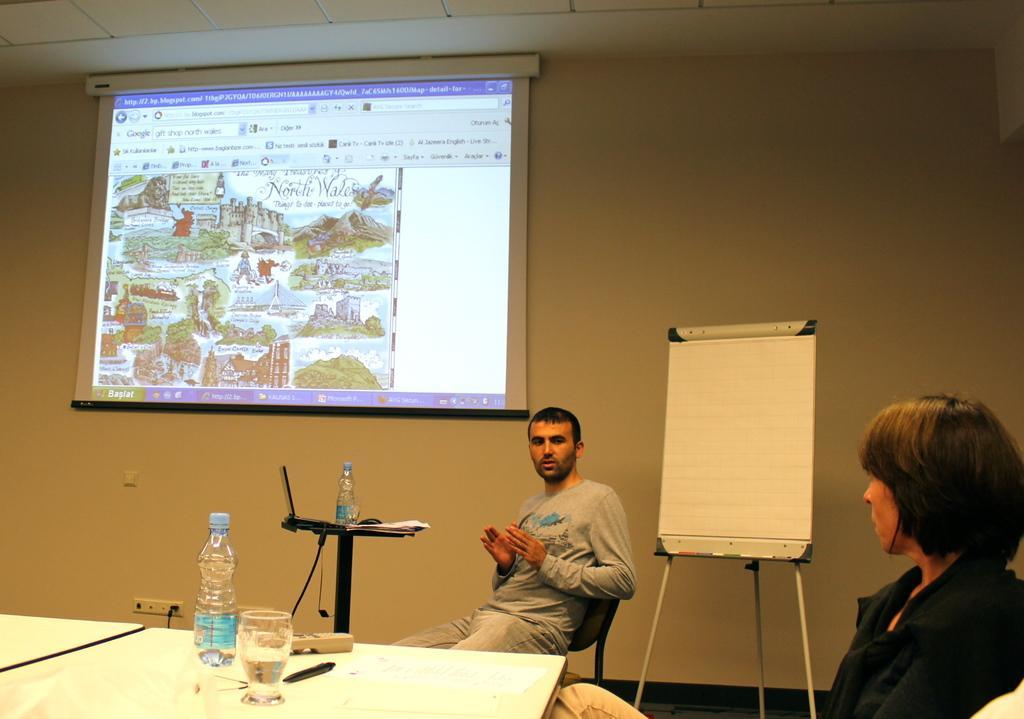Could you give a brief overview of what you see in this image? In the center of the image we can see two persons are sitting. And we can see tables, water bottles, one glass and some objects. In the background there is a wall, roof, board, switchboard and a screen. On the screen, we can see some text and some objects. 